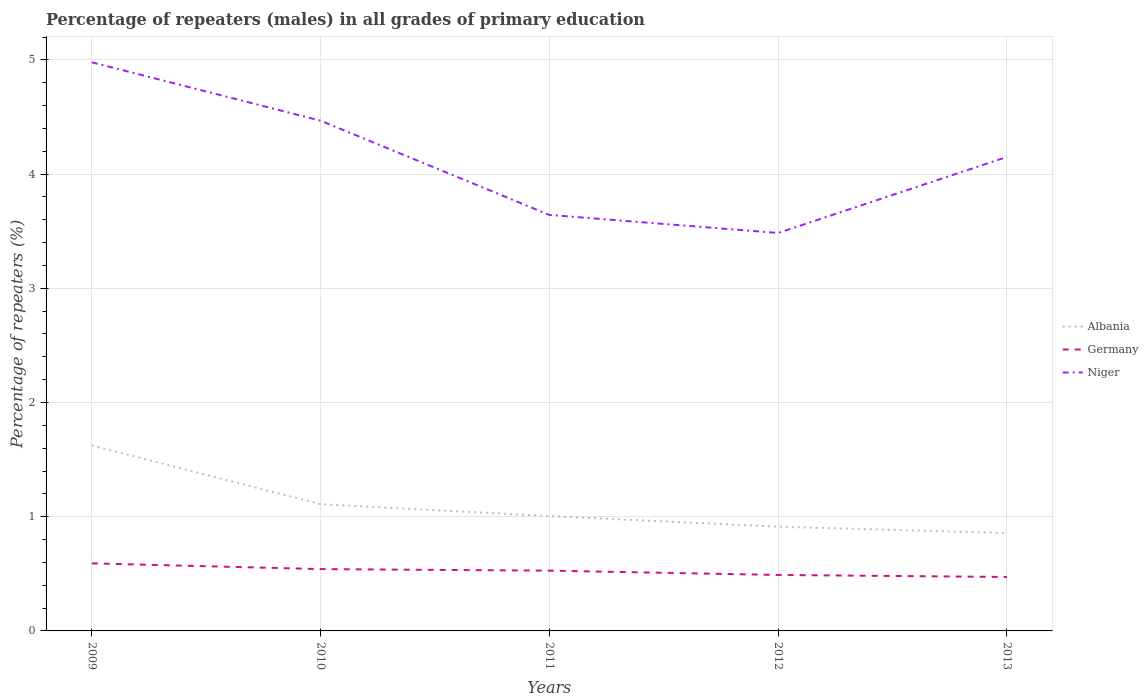How many different coloured lines are there?
Keep it short and to the point. 3. Is the number of lines equal to the number of legend labels?
Provide a short and direct response. Yes. Across all years, what is the maximum percentage of repeaters (males) in Germany?
Give a very brief answer. 0.47. In which year was the percentage of repeaters (males) in Germany maximum?
Provide a short and direct response. 2013. What is the total percentage of repeaters (males) in Albania in the graph?
Offer a terse response. 0.51. What is the difference between the highest and the second highest percentage of repeaters (males) in Germany?
Keep it short and to the point. 0.12. What is the difference between two consecutive major ticks on the Y-axis?
Ensure brevity in your answer.  1. Are the values on the major ticks of Y-axis written in scientific E-notation?
Provide a succinct answer. No. Does the graph contain any zero values?
Your answer should be very brief. No. Where does the legend appear in the graph?
Your response must be concise. Center right. How are the legend labels stacked?
Keep it short and to the point. Vertical. What is the title of the graph?
Give a very brief answer. Percentage of repeaters (males) in all grades of primary education. Does "Cabo Verde" appear as one of the legend labels in the graph?
Provide a short and direct response. No. What is the label or title of the Y-axis?
Give a very brief answer. Percentage of repeaters (%). What is the Percentage of repeaters (%) of Albania in 2009?
Offer a very short reply. 1.62. What is the Percentage of repeaters (%) of Germany in 2009?
Offer a terse response. 0.59. What is the Percentage of repeaters (%) of Niger in 2009?
Offer a terse response. 4.98. What is the Percentage of repeaters (%) in Albania in 2010?
Offer a very short reply. 1.11. What is the Percentage of repeaters (%) of Germany in 2010?
Your response must be concise. 0.54. What is the Percentage of repeaters (%) of Niger in 2010?
Provide a short and direct response. 4.47. What is the Percentage of repeaters (%) in Albania in 2011?
Ensure brevity in your answer.  1.01. What is the Percentage of repeaters (%) of Germany in 2011?
Provide a short and direct response. 0.53. What is the Percentage of repeaters (%) of Niger in 2011?
Your answer should be very brief. 3.64. What is the Percentage of repeaters (%) in Albania in 2012?
Provide a succinct answer. 0.91. What is the Percentage of repeaters (%) in Germany in 2012?
Keep it short and to the point. 0.49. What is the Percentage of repeaters (%) of Niger in 2012?
Keep it short and to the point. 3.48. What is the Percentage of repeaters (%) in Albania in 2013?
Your answer should be compact. 0.86. What is the Percentage of repeaters (%) of Germany in 2013?
Offer a terse response. 0.47. What is the Percentage of repeaters (%) of Niger in 2013?
Your response must be concise. 4.15. Across all years, what is the maximum Percentage of repeaters (%) of Albania?
Your response must be concise. 1.62. Across all years, what is the maximum Percentage of repeaters (%) in Germany?
Provide a short and direct response. 0.59. Across all years, what is the maximum Percentage of repeaters (%) in Niger?
Your answer should be compact. 4.98. Across all years, what is the minimum Percentage of repeaters (%) of Albania?
Provide a short and direct response. 0.86. Across all years, what is the minimum Percentage of repeaters (%) in Germany?
Offer a terse response. 0.47. Across all years, what is the minimum Percentage of repeaters (%) of Niger?
Ensure brevity in your answer.  3.48. What is the total Percentage of repeaters (%) of Albania in the graph?
Your response must be concise. 5.51. What is the total Percentage of repeaters (%) in Germany in the graph?
Your answer should be compact. 2.62. What is the total Percentage of repeaters (%) in Niger in the graph?
Offer a terse response. 20.72. What is the difference between the Percentage of repeaters (%) of Albania in 2009 and that in 2010?
Ensure brevity in your answer.  0.51. What is the difference between the Percentage of repeaters (%) of Germany in 2009 and that in 2010?
Ensure brevity in your answer.  0.05. What is the difference between the Percentage of repeaters (%) in Niger in 2009 and that in 2010?
Provide a short and direct response. 0.51. What is the difference between the Percentage of repeaters (%) in Albania in 2009 and that in 2011?
Offer a very short reply. 0.62. What is the difference between the Percentage of repeaters (%) in Germany in 2009 and that in 2011?
Ensure brevity in your answer.  0.06. What is the difference between the Percentage of repeaters (%) of Niger in 2009 and that in 2011?
Make the answer very short. 1.34. What is the difference between the Percentage of repeaters (%) of Albania in 2009 and that in 2012?
Provide a succinct answer. 0.71. What is the difference between the Percentage of repeaters (%) in Germany in 2009 and that in 2012?
Your response must be concise. 0.1. What is the difference between the Percentage of repeaters (%) of Niger in 2009 and that in 2012?
Your response must be concise. 1.49. What is the difference between the Percentage of repeaters (%) in Albania in 2009 and that in 2013?
Your answer should be compact. 0.77. What is the difference between the Percentage of repeaters (%) of Germany in 2009 and that in 2013?
Give a very brief answer. 0.12. What is the difference between the Percentage of repeaters (%) of Niger in 2009 and that in 2013?
Your answer should be very brief. 0.83. What is the difference between the Percentage of repeaters (%) of Albania in 2010 and that in 2011?
Offer a terse response. 0.1. What is the difference between the Percentage of repeaters (%) in Germany in 2010 and that in 2011?
Offer a terse response. 0.01. What is the difference between the Percentage of repeaters (%) in Niger in 2010 and that in 2011?
Make the answer very short. 0.83. What is the difference between the Percentage of repeaters (%) in Albania in 2010 and that in 2012?
Your answer should be very brief. 0.2. What is the difference between the Percentage of repeaters (%) of Germany in 2010 and that in 2012?
Offer a terse response. 0.05. What is the difference between the Percentage of repeaters (%) of Niger in 2010 and that in 2012?
Provide a short and direct response. 0.98. What is the difference between the Percentage of repeaters (%) of Albania in 2010 and that in 2013?
Ensure brevity in your answer.  0.25. What is the difference between the Percentage of repeaters (%) in Germany in 2010 and that in 2013?
Ensure brevity in your answer.  0.07. What is the difference between the Percentage of repeaters (%) of Niger in 2010 and that in 2013?
Offer a terse response. 0.32. What is the difference between the Percentage of repeaters (%) in Albania in 2011 and that in 2012?
Offer a terse response. 0.09. What is the difference between the Percentage of repeaters (%) of Germany in 2011 and that in 2012?
Keep it short and to the point. 0.04. What is the difference between the Percentage of repeaters (%) in Niger in 2011 and that in 2012?
Offer a very short reply. 0.16. What is the difference between the Percentage of repeaters (%) in Albania in 2011 and that in 2013?
Keep it short and to the point. 0.15. What is the difference between the Percentage of repeaters (%) of Germany in 2011 and that in 2013?
Make the answer very short. 0.06. What is the difference between the Percentage of repeaters (%) in Niger in 2011 and that in 2013?
Make the answer very short. -0.51. What is the difference between the Percentage of repeaters (%) in Albania in 2012 and that in 2013?
Provide a succinct answer. 0.06. What is the difference between the Percentage of repeaters (%) in Germany in 2012 and that in 2013?
Ensure brevity in your answer.  0.02. What is the difference between the Percentage of repeaters (%) in Niger in 2012 and that in 2013?
Offer a very short reply. -0.67. What is the difference between the Percentage of repeaters (%) in Albania in 2009 and the Percentage of repeaters (%) in Germany in 2010?
Your response must be concise. 1.08. What is the difference between the Percentage of repeaters (%) in Albania in 2009 and the Percentage of repeaters (%) in Niger in 2010?
Provide a short and direct response. -2.84. What is the difference between the Percentage of repeaters (%) in Germany in 2009 and the Percentage of repeaters (%) in Niger in 2010?
Your answer should be compact. -3.88. What is the difference between the Percentage of repeaters (%) in Albania in 2009 and the Percentage of repeaters (%) in Germany in 2011?
Provide a short and direct response. 1.1. What is the difference between the Percentage of repeaters (%) in Albania in 2009 and the Percentage of repeaters (%) in Niger in 2011?
Give a very brief answer. -2.02. What is the difference between the Percentage of repeaters (%) in Germany in 2009 and the Percentage of repeaters (%) in Niger in 2011?
Your answer should be compact. -3.05. What is the difference between the Percentage of repeaters (%) of Albania in 2009 and the Percentage of repeaters (%) of Germany in 2012?
Make the answer very short. 1.13. What is the difference between the Percentage of repeaters (%) in Albania in 2009 and the Percentage of repeaters (%) in Niger in 2012?
Offer a very short reply. -1.86. What is the difference between the Percentage of repeaters (%) of Germany in 2009 and the Percentage of repeaters (%) of Niger in 2012?
Your response must be concise. -2.89. What is the difference between the Percentage of repeaters (%) in Albania in 2009 and the Percentage of repeaters (%) in Germany in 2013?
Provide a short and direct response. 1.15. What is the difference between the Percentage of repeaters (%) in Albania in 2009 and the Percentage of repeaters (%) in Niger in 2013?
Your answer should be very brief. -2.53. What is the difference between the Percentage of repeaters (%) in Germany in 2009 and the Percentage of repeaters (%) in Niger in 2013?
Your answer should be very brief. -3.56. What is the difference between the Percentage of repeaters (%) of Albania in 2010 and the Percentage of repeaters (%) of Germany in 2011?
Your answer should be compact. 0.58. What is the difference between the Percentage of repeaters (%) of Albania in 2010 and the Percentage of repeaters (%) of Niger in 2011?
Give a very brief answer. -2.53. What is the difference between the Percentage of repeaters (%) in Germany in 2010 and the Percentage of repeaters (%) in Niger in 2011?
Provide a short and direct response. -3.1. What is the difference between the Percentage of repeaters (%) in Albania in 2010 and the Percentage of repeaters (%) in Germany in 2012?
Provide a short and direct response. 0.62. What is the difference between the Percentage of repeaters (%) of Albania in 2010 and the Percentage of repeaters (%) of Niger in 2012?
Offer a very short reply. -2.37. What is the difference between the Percentage of repeaters (%) in Germany in 2010 and the Percentage of repeaters (%) in Niger in 2012?
Provide a short and direct response. -2.94. What is the difference between the Percentage of repeaters (%) of Albania in 2010 and the Percentage of repeaters (%) of Germany in 2013?
Ensure brevity in your answer.  0.64. What is the difference between the Percentage of repeaters (%) of Albania in 2010 and the Percentage of repeaters (%) of Niger in 2013?
Your response must be concise. -3.04. What is the difference between the Percentage of repeaters (%) in Germany in 2010 and the Percentage of repeaters (%) in Niger in 2013?
Your answer should be compact. -3.61. What is the difference between the Percentage of repeaters (%) of Albania in 2011 and the Percentage of repeaters (%) of Germany in 2012?
Provide a short and direct response. 0.52. What is the difference between the Percentage of repeaters (%) of Albania in 2011 and the Percentage of repeaters (%) of Niger in 2012?
Offer a very short reply. -2.48. What is the difference between the Percentage of repeaters (%) in Germany in 2011 and the Percentage of repeaters (%) in Niger in 2012?
Offer a terse response. -2.96. What is the difference between the Percentage of repeaters (%) in Albania in 2011 and the Percentage of repeaters (%) in Germany in 2013?
Your answer should be very brief. 0.53. What is the difference between the Percentage of repeaters (%) of Albania in 2011 and the Percentage of repeaters (%) of Niger in 2013?
Make the answer very short. -3.14. What is the difference between the Percentage of repeaters (%) in Germany in 2011 and the Percentage of repeaters (%) in Niger in 2013?
Provide a short and direct response. -3.62. What is the difference between the Percentage of repeaters (%) in Albania in 2012 and the Percentage of repeaters (%) in Germany in 2013?
Keep it short and to the point. 0.44. What is the difference between the Percentage of repeaters (%) of Albania in 2012 and the Percentage of repeaters (%) of Niger in 2013?
Your answer should be very brief. -3.24. What is the difference between the Percentage of repeaters (%) in Germany in 2012 and the Percentage of repeaters (%) in Niger in 2013?
Your response must be concise. -3.66. What is the average Percentage of repeaters (%) of Albania per year?
Offer a terse response. 1.1. What is the average Percentage of repeaters (%) of Germany per year?
Your response must be concise. 0.52. What is the average Percentage of repeaters (%) in Niger per year?
Give a very brief answer. 4.14. In the year 2009, what is the difference between the Percentage of repeaters (%) in Albania and Percentage of repeaters (%) in Germany?
Offer a very short reply. 1.03. In the year 2009, what is the difference between the Percentage of repeaters (%) in Albania and Percentage of repeaters (%) in Niger?
Keep it short and to the point. -3.35. In the year 2009, what is the difference between the Percentage of repeaters (%) in Germany and Percentage of repeaters (%) in Niger?
Your answer should be compact. -4.39. In the year 2010, what is the difference between the Percentage of repeaters (%) of Albania and Percentage of repeaters (%) of Germany?
Provide a short and direct response. 0.57. In the year 2010, what is the difference between the Percentage of repeaters (%) in Albania and Percentage of repeaters (%) in Niger?
Keep it short and to the point. -3.36. In the year 2010, what is the difference between the Percentage of repeaters (%) of Germany and Percentage of repeaters (%) of Niger?
Your answer should be compact. -3.93. In the year 2011, what is the difference between the Percentage of repeaters (%) of Albania and Percentage of repeaters (%) of Germany?
Your response must be concise. 0.48. In the year 2011, what is the difference between the Percentage of repeaters (%) of Albania and Percentage of repeaters (%) of Niger?
Offer a very short reply. -2.64. In the year 2011, what is the difference between the Percentage of repeaters (%) in Germany and Percentage of repeaters (%) in Niger?
Give a very brief answer. -3.11. In the year 2012, what is the difference between the Percentage of repeaters (%) in Albania and Percentage of repeaters (%) in Germany?
Your response must be concise. 0.42. In the year 2012, what is the difference between the Percentage of repeaters (%) of Albania and Percentage of repeaters (%) of Niger?
Your answer should be very brief. -2.57. In the year 2012, what is the difference between the Percentage of repeaters (%) in Germany and Percentage of repeaters (%) in Niger?
Provide a succinct answer. -2.99. In the year 2013, what is the difference between the Percentage of repeaters (%) in Albania and Percentage of repeaters (%) in Germany?
Your answer should be compact. 0.38. In the year 2013, what is the difference between the Percentage of repeaters (%) in Albania and Percentage of repeaters (%) in Niger?
Your answer should be compact. -3.29. In the year 2013, what is the difference between the Percentage of repeaters (%) in Germany and Percentage of repeaters (%) in Niger?
Ensure brevity in your answer.  -3.68. What is the ratio of the Percentage of repeaters (%) in Albania in 2009 to that in 2010?
Offer a terse response. 1.46. What is the ratio of the Percentage of repeaters (%) in Germany in 2009 to that in 2010?
Give a very brief answer. 1.09. What is the ratio of the Percentage of repeaters (%) in Niger in 2009 to that in 2010?
Give a very brief answer. 1.11. What is the ratio of the Percentage of repeaters (%) in Albania in 2009 to that in 2011?
Keep it short and to the point. 1.62. What is the ratio of the Percentage of repeaters (%) in Germany in 2009 to that in 2011?
Your answer should be very brief. 1.12. What is the ratio of the Percentage of repeaters (%) of Niger in 2009 to that in 2011?
Your answer should be compact. 1.37. What is the ratio of the Percentage of repeaters (%) in Albania in 2009 to that in 2012?
Ensure brevity in your answer.  1.78. What is the ratio of the Percentage of repeaters (%) of Germany in 2009 to that in 2012?
Your response must be concise. 1.21. What is the ratio of the Percentage of repeaters (%) in Niger in 2009 to that in 2012?
Your answer should be very brief. 1.43. What is the ratio of the Percentage of repeaters (%) of Albania in 2009 to that in 2013?
Provide a short and direct response. 1.89. What is the ratio of the Percentage of repeaters (%) of Germany in 2009 to that in 2013?
Offer a very short reply. 1.25. What is the ratio of the Percentage of repeaters (%) of Niger in 2009 to that in 2013?
Your answer should be very brief. 1.2. What is the ratio of the Percentage of repeaters (%) in Albania in 2010 to that in 2011?
Ensure brevity in your answer.  1.1. What is the ratio of the Percentage of repeaters (%) of Germany in 2010 to that in 2011?
Your answer should be compact. 1.03. What is the ratio of the Percentage of repeaters (%) in Niger in 2010 to that in 2011?
Ensure brevity in your answer.  1.23. What is the ratio of the Percentage of repeaters (%) of Albania in 2010 to that in 2012?
Offer a terse response. 1.22. What is the ratio of the Percentage of repeaters (%) of Germany in 2010 to that in 2012?
Your answer should be very brief. 1.1. What is the ratio of the Percentage of repeaters (%) in Niger in 2010 to that in 2012?
Provide a short and direct response. 1.28. What is the ratio of the Percentage of repeaters (%) of Albania in 2010 to that in 2013?
Offer a terse response. 1.29. What is the ratio of the Percentage of repeaters (%) in Germany in 2010 to that in 2013?
Your answer should be very brief. 1.15. What is the ratio of the Percentage of repeaters (%) in Niger in 2010 to that in 2013?
Your answer should be compact. 1.08. What is the ratio of the Percentage of repeaters (%) in Albania in 2011 to that in 2012?
Your answer should be very brief. 1.1. What is the ratio of the Percentage of repeaters (%) in Germany in 2011 to that in 2012?
Your answer should be very brief. 1.08. What is the ratio of the Percentage of repeaters (%) of Niger in 2011 to that in 2012?
Provide a succinct answer. 1.05. What is the ratio of the Percentage of repeaters (%) of Albania in 2011 to that in 2013?
Keep it short and to the point. 1.17. What is the ratio of the Percentage of repeaters (%) in Germany in 2011 to that in 2013?
Provide a succinct answer. 1.12. What is the ratio of the Percentage of repeaters (%) in Niger in 2011 to that in 2013?
Ensure brevity in your answer.  0.88. What is the ratio of the Percentage of repeaters (%) of Albania in 2012 to that in 2013?
Ensure brevity in your answer.  1.06. What is the ratio of the Percentage of repeaters (%) in Germany in 2012 to that in 2013?
Provide a succinct answer. 1.04. What is the ratio of the Percentage of repeaters (%) of Niger in 2012 to that in 2013?
Your answer should be very brief. 0.84. What is the difference between the highest and the second highest Percentage of repeaters (%) in Albania?
Your answer should be compact. 0.51. What is the difference between the highest and the second highest Percentage of repeaters (%) in Germany?
Ensure brevity in your answer.  0.05. What is the difference between the highest and the second highest Percentage of repeaters (%) in Niger?
Offer a terse response. 0.51. What is the difference between the highest and the lowest Percentage of repeaters (%) in Albania?
Make the answer very short. 0.77. What is the difference between the highest and the lowest Percentage of repeaters (%) in Germany?
Offer a terse response. 0.12. What is the difference between the highest and the lowest Percentage of repeaters (%) in Niger?
Your answer should be very brief. 1.49. 